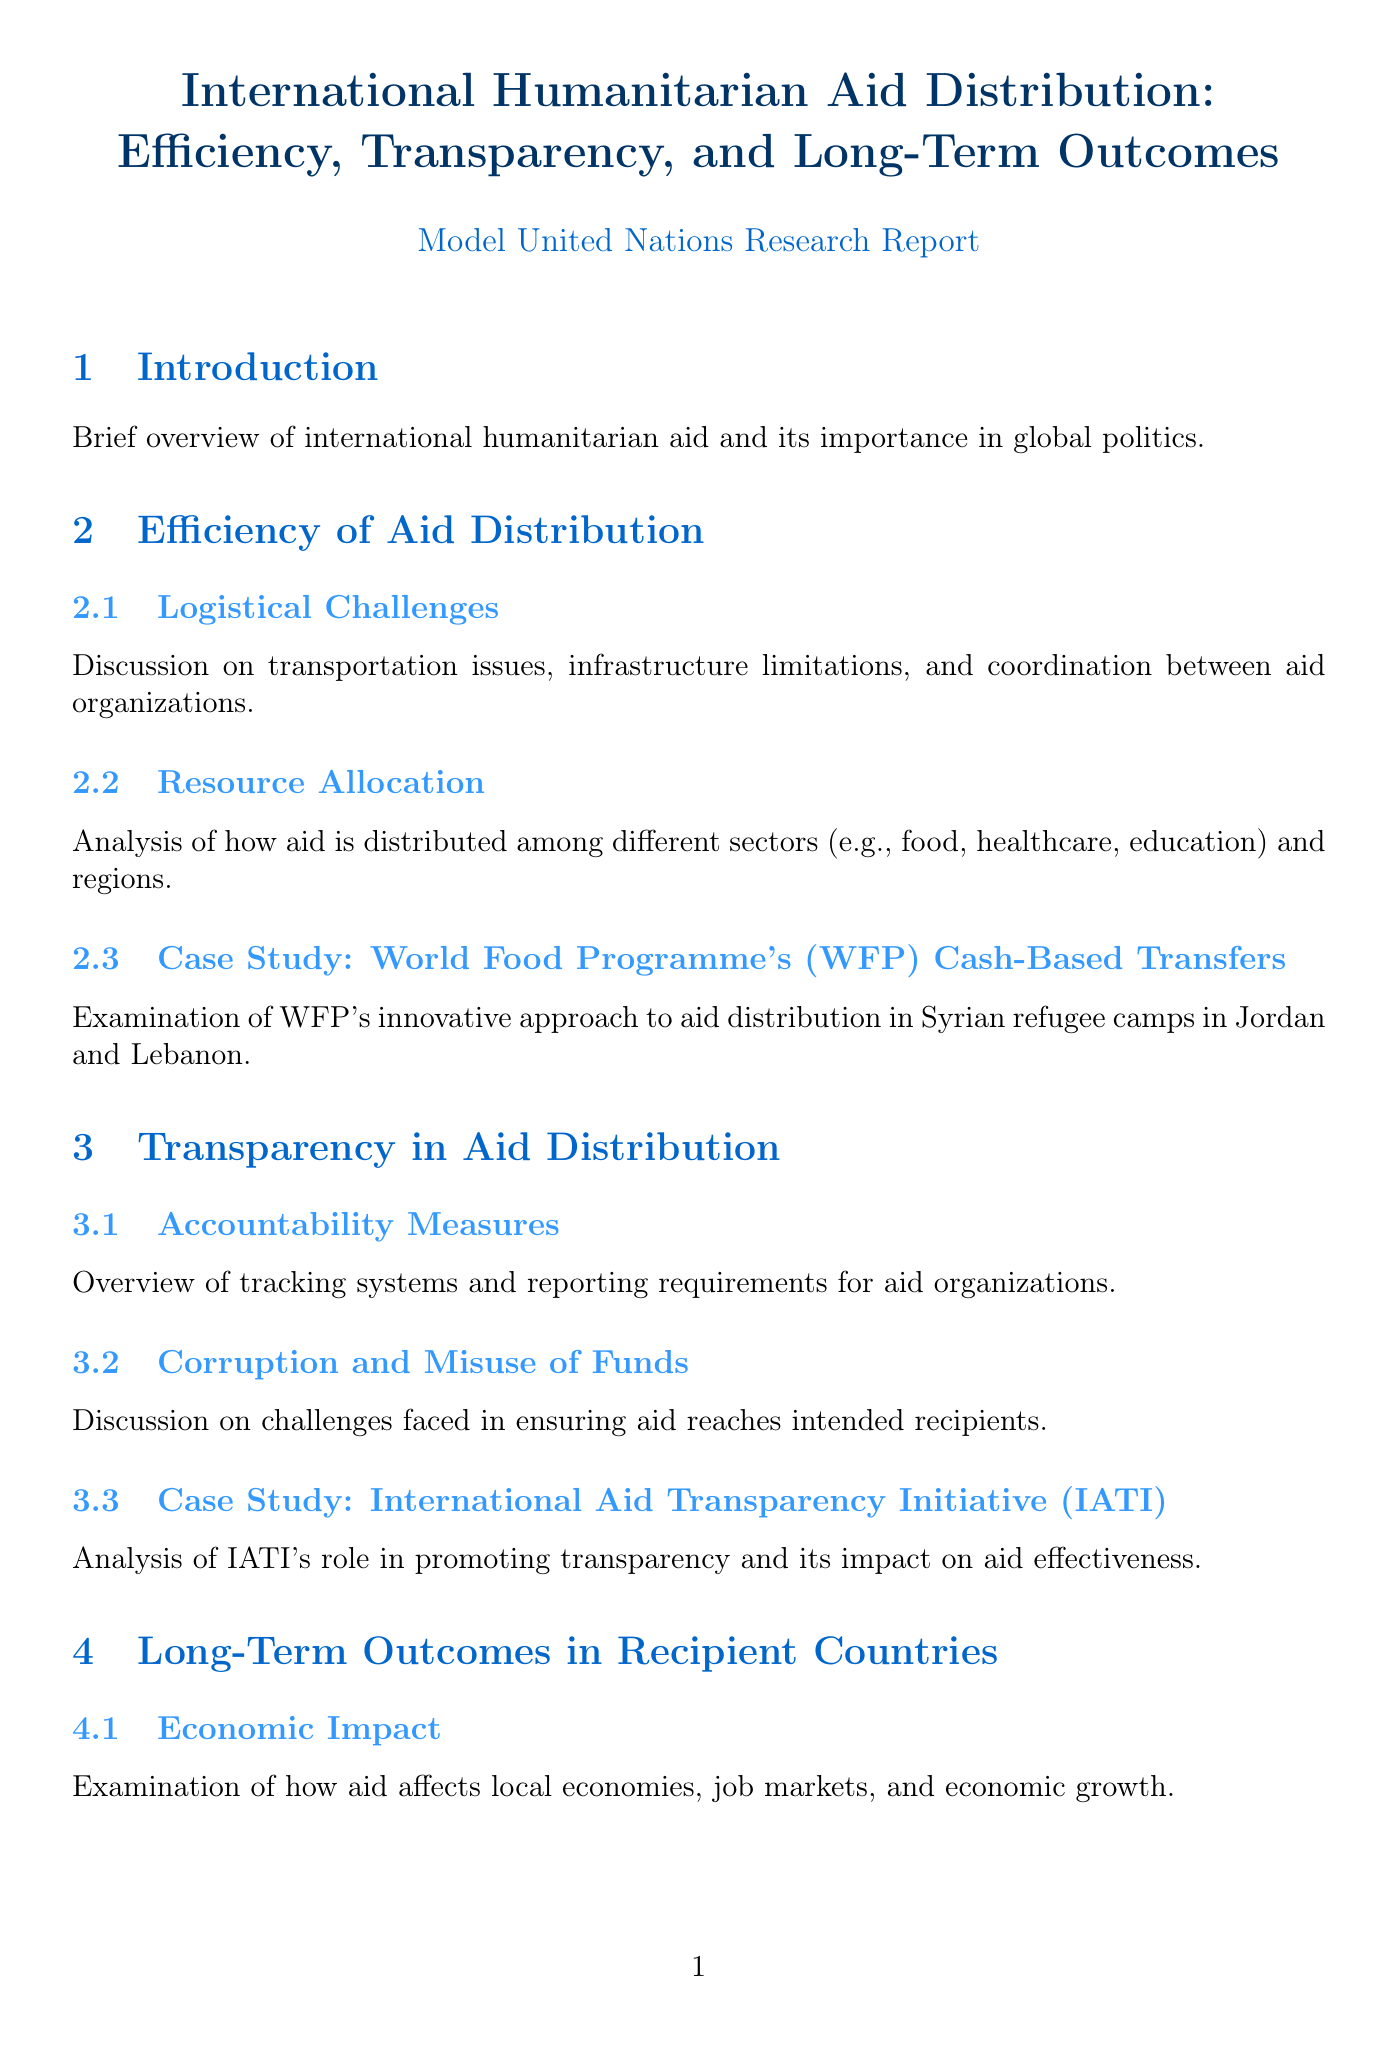What is the title of the report? The title of the report is explicitly mentioned at the beginning of the document.
Answer: International Humanitarian Aid Distribution: Efficiency, Transparency, and Long-Term Outcomes What year did the World Food Programme reach 38.4 million people with cash-based transfers? The report provides specific statistics related to humanitarian aid for the year 2020.
Answer: 2020 What percentage of aid is estimated to be lost to corruption? The document includes statistics that quantify the loss of aid due to corruption.
Answer: 10-30% Which organization is responsible for coordinating humanitarian response to emergencies? The report lists relevant organizations and their descriptions, including a specific one that handles emergency response.
Answer: United Nations Office for the Coordination of Humanitarian Affairs (OCHA) What case study analyzes the Marshall Plan? The report includes several case studies, one focusing on the historical implications of the Marshall Plan for European reconstruction.
Answer: Case Study: Marshall Plan What key area does the Economic and Social Council (ECOSOC) coordinate? The document discusses the roles of various UN resources and their specific focuses on aid and development.
Answer: Economic and social work of UN agencies What is one challenge discussed in the section on transparency? The section on transparency addresses various challenges faced by aid organizations, with a specific mention of one issue.
Answer: Corruption and Misuse of Funds Which organization is noted for addressing hunger and promoting food security? The report lists organizations and describes their primary functions, identifying one specific organization focused on food security.
Answer: World Food Programme (WFP) 